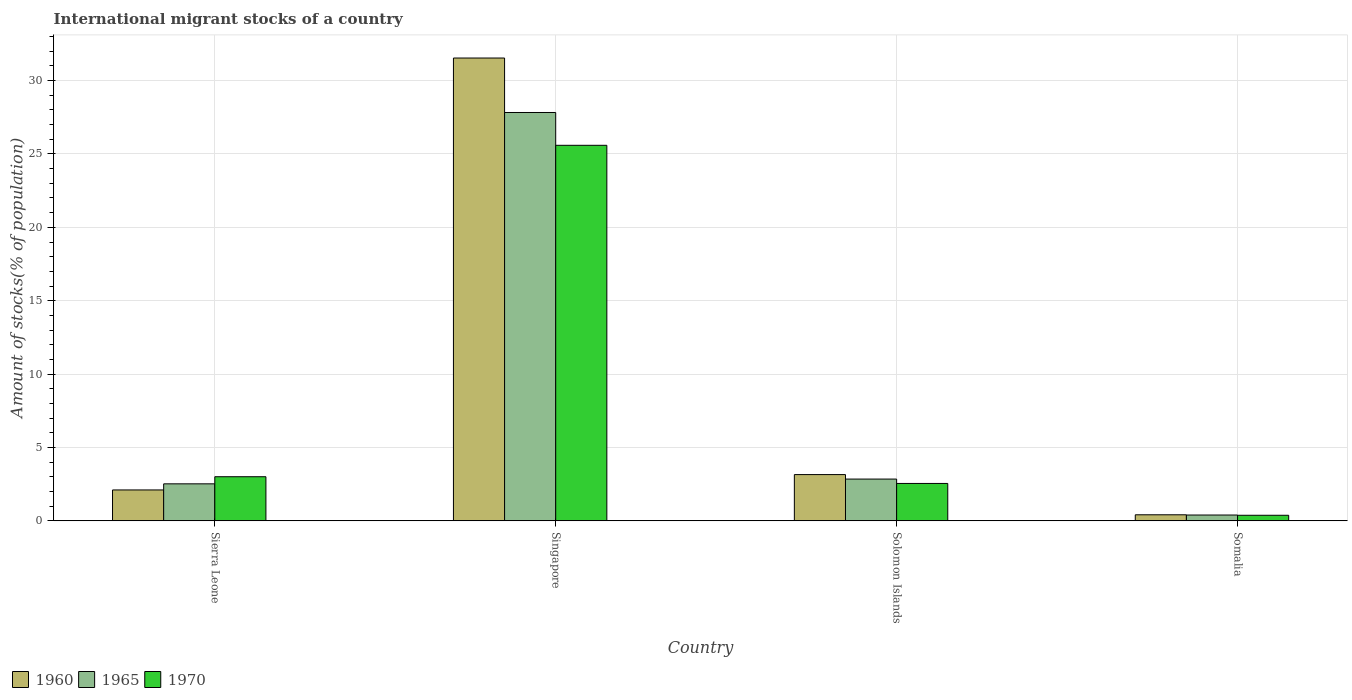How many different coloured bars are there?
Keep it short and to the point. 3. How many groups of bars are there?
Make the answer very short. 4. Are the number of bars per tick equal to the number of legend labels?
Provide a short and direct response. Yes. Are the number of bars on each tick of the X-axis equal?
Make the answer very short. Yes. How many bars are there on the 1st tick from the right?
Offer a terse response. 3. What is the label of the 3rd group of bars from the left?
Offer a very short reply. Solomon Islands. In how many cases, is the number of bars for a given country not equal to the number of legend labels?
Your answer should be compact. 0. What is the amount of stocks in in 1970 in Sierra Leone?
Your response must be concise. 3.01. Across all countries, what is the maximum amount of stocks in in 1960?
Your answer should be compact. 31.54. Across all countries, what is the minimum amount of stocks in in 1960?
Offer a very short reply. 0.41. In which country was the amount of stocks in in 1960 maximum?
Offer a terse response. Singapore. In which country was the amount of stocks in in 1965 minimum?
Your answer should be very brief. Somalia. What is the total amount of stocks in in 1960 in the graph?
Offer a very short reply. 37.21. What is the difference between the amount of stocks in in 1970 in Sierra Leone and that in Solomon Islands?
Keep it short and to the point. 0.46. What is the difference between the amount of stocks in in 1965 in Somalia and the amount of stocks in in 1970 in Solomon Islands?
Give a very brief answer. -2.15. What is the average amount of stocks in in 1960 per country?
Offer a terse response. 9.3. What is the difference between the amount of stocks in of/in 1970 and amount of stocks in of/in 1965 in Singapore?
Make the answer very short. -2.24. What is the ratio of the amount of stocks in in 1965 in Singapore to that in Somalia?
Offer a terse response. 70.38. Is the amount of stocks in in 1960 in Singapore less than that in Solomon Islands?
Your answer should be compact. No. What is the difference between the highest and the second highest amount of stocks in in 1970?
Offer a very short reply. 23.04. What is the difference between the highest and the lowest amount of stocks in in 1960?
Your answer should be compact. 31.13. Is the sum of the amount of stocks in in 1960 in Sierra Leone and Solomon Islands greater than the maximum amount of stocks in in 1965 across all countries?
Offer a terse response. No. What does the 1st bar from the left in Sierra Leone represents?
Make the answer very short. 1960. What does the 2nd bar from the right in Somalia represents?
Your response must be concise. 1965. Is it the case that in every country, the sum of the amount of stocks in in 1965 and amount of stocks in in 1970 is greater than the amount of stocks in in 1960?
Provide a short and direct response. Yes. Are all the bars in the graph horizontal?
Make the answer very short. No. How many countries are there in the graph?
Your response must be concise. 4. What is the difference between two consecutive major ticks on the Y-axis?
Give a very brief answer. 5. Are the values on the major ticks of Y-axis written in scientific E-notation?
Your answer should be very brief. No. How many legend labels are there?
Make the answer very short. 3. How are the legend labels stacked?
Offer a terse response. Horizontal. What is the title of the graph?
Make the answer very short. International migrant stocks of a country. Does "1974" appear as one of the legend labels in the graph?
Give a very brief answer. No. What is the label or title of the Y-axis?
Give a very brief answer. Amount of stocks(% of population). What is the Amount of stocks(% of population) in 1960 in Sierra Leone?
Your answer should be very brief. 2.1. What is the Amount of stocks(% of population) in 1965 in Sierra Leone?
Offer a terse response. 2.52. What is the Amount of stocks(% of population) in 1970 in Sierra Leone?
Ensure brevity in your answer.  3.01. What is the Amount of stocks(% of population) in 1960 in Singapore?
Ensure brevity in your answer.  31.54. What is the Amount of stocks(% of population) of 1965 in Singapore?
Give a very brief answer. 27.83. What is the Amount of stocks(% of population) of 1970 in Singapore?
Make the answer very short. 25.59. What is the Amount of stocks(% of population) in 1960 in Solomon Islands?
Your answer should be very brief. 3.15. What is the Amount of stocks(% of population) of 1965 in Solomon Islands?
Ensure brevity in your answer.  2.85. What is the Amount of stocks(% of population) of 1970 in Solomon Islands?
Offer a very short reply. 2.55. What is the Amount of stocks(% of population) of 1960 in Somalia?
Your answer should be compact. 0.41. What is the Amount of stocks(% of population) of 1965 in Somalia?
Give a very brief answer. 0.4. What is the Amount of stocks(% of population) of 1970 in Somalia?
Keep it short and to the point. 0.38. Across all countries, what is the maximum Amount of stocks(% of population) in 1960?
Your answer should be compact. 31.54. Across all countries, what is the maximum Amount of stocks(% of population) in 1965?
Give a very brief answer. 27.83. Across all countries, what is the maximum Amount of stocks(% of population) in 1970?
Provide a short and direct response. 25.59. Across all countries, what is the minimum Amount of stocks(% of population) in 1960?
Give a very brief answer. 0.41. Across all countries, what is the minimum Amount of stocks(% of population) in 1965?
Give a very brief answer. 0.4. Across all countries, what is the minimum Amount of stocks(% of population) in 1970?
Give a very brief answer. 0.38. What is the total Amount of stocks(% of population) in 1960 in the graph?
Your answer should be very brief. 37.21. What is the total Amount of stocks(% of population) in 1965 in the graph?
Offer a very short reply. 33.59. What is the total Amount of stocks(% of population) in 1970 in the graph?
Ensure brevity in your answer.  31.52. What is the difference between the Amount of stocks(% of population) of 1960 in Sierra Leone and that in Singapore?
Ensure brevity in your answer.  -29.43. What is the difference between the Amount of stocks(% of population) of 1965 in Sierra Leone and that in Singapore?
Provide a short and direct response. -25.31. What is the difference between the Amount of stocks(% of population) in 1970 in Sierra Leone and that in Singapore?
Ensure brevity in your answer.  -22.58. What is the difference between the Amount of stocks(% of population) of 1960 in Sierra Leone and that in Solomon Islands?
Offer a terse response. -1.05. What is the difference between the Amount of stocks(% of population) in 1965 in Sierra Leone and that in Solomon Islands?
Offer a very short reply. -0.33. What is the difference between the Amount of stocks(% of population) of 1970 in Sierra Leone and that in Solomon Islands?
Provide a short and direct response. 0.46. What is the difference between the Amount of stocks(% of population) in 1960 in Sierra Leone and that in Somalia?
Your response must be concise. 1.69. What is the difference between the Amount of stocks(% of population) in 1965 in Sierra Leone and that in Somalia?
Your answer should be compact. 2.13. What is the difference between the Amount of stocks(% of population) of 1970 in Sierra Leone and that in Somalia?
Provide a short and direct response. 2.63. What is the difference between the Amount of stocks(% of population) of 1960 in Singapore and that in Solomon Islands?
Provide a short and direct response. 28.39. What is the difference between the Amount of stocks(% of population) of 1965 in Singapore and that in Solomon Islands?
Give a very brief answer. 24.98. What is the difference between the Amount of stocks(% of population) of 1970 in Singapore and that in Solomon Islands?
Provide a succinct answer. 23.04. What is the difference between the Amount of stocks(% of population) of 1960 in Singapore and that in Somalia?
Keep it short and to the point. 31.13. What is the difference between the Amount of stocks(% of population) of 1965 in Singapore and that in Somalia?
Make the answer very short. 27.43. What is the difference between the Amount of stocks(% of population) of 1970 in Singapore and that in Somalia?
Offer a very short reply. 25.21. What is the difference between the Amount of stocks(% of population) of 1960 in Solomon Islands and that in Somalia?
Your response must be concise. 2.74. What is the difference between the Amount of stocks(% of population) of 1965 in Solomon Islands and that in Somalia?
Give a very brief answer. 2.45. What is the difference between the Amount of stocks(% of population) in 1970 in Solomon Islands and that in Somalia?
Keep it short and to the point. 2.17. What is the difference between the Amount of stocks(% of population) in 1960 in Sierra Leone and the Amount of stocks(% of population) in 1965 in Singapore?
Provide a succinct answer. -25.72. What is the difference between the Amount of stocks(% of population) of 1960 in Sierra Leone and the Amount of stocks(% of population) of 1970 in Singapore?
Your answer should be very brief. -23.49. What is the difference between the Amount of stocks(% of population) in 1965 in Sierra Leone and the Amount of stocks(% of population) in 1970 in Singapore?
Provide a succinct answer. -23.07. What is the difference between the Amount of stocks(% of population) of 1960 in Sierra Leone and the Amount of stocks(% of population) of 1965 in Solomon Islands?
Your response must be concise. -0.74. What is the difference between the Amount of stocks(% of population) of 1960 in Sierra Leone and the Amount of stocks(% of population) of 1970 in Solomon Islands?
Give a very brief answer. -0.44. What is the difference between the Amount of stocks(% of population) of 1965 in Sierra Leone and the Amount of stocks(% of population) of 1970 in Solomon Islands?
Keep it short and to the point. -0.03. What is the difference between the Amount of stocks(% of population) of 1960 in Sierra Leone and the Amount of stocks(% of population) of 1965 in Somalia?
Make the answer very short. 1.71. What is the difference between the Amount of stocks(% of population) of 1960 in Sierra Leone and the Amount of stocks(% of population) of 1970 in Somalia?
Provide a short and direct response. 1.73. What is the difference between the Amount of stocks(% of population) in 1965 in Sierra Leone and the Amount of stocks(% of population) in 1970 in Somalia?
Give a very brief answer. 2.14. What is the difference between the Amount of stocks(% of population) in 1960 in Singapore and the Amount of stocks(% of population) in 1965 in Solomon Islands?
Offer a very short reply. 28.69. What is the difference between the Amount of stocks(% of population) of 1960 in Singapore and the Amount of stocks(% of population) of 1970 in Solomon Islands?
Your response must be concise. 28.99. What is the difference between the Amount of stocks(% of population) of 1965 in Singapore and the Amount of stocks(% of population) of 1970 in Solomon Islands?
Your answer should be compact. 25.28. What is the difference between the Amount of stocks(% of population) in 1960 in Singapore and the Amount of stocks(% of population) in 1965 in Somalia?
Give a very brief answer. 31.14. What is the difference between the Amount of stocks(% of population) in 1960 in Singapore and the Amount of stocks(% of population) in 1970 in Somalia?
Provide a short and direct response. 31.16. What is the difference between the Amount of stocks(% of population) in 1965 in Singapore and the Amount of stocks(% of population) in 1970 in Somalia?
Make the answer very short. 27.45. What is the difference between the Amount of stocks(% of population) in 1960 in Solomon Islands and the Amount of stocks(% of population) in 1965 in Somalia?
Your response must be concise. 2.76. What is the difference between the Amount of stocks(% of population) in 1960 in Solomon Islands and the Amount of stocks(% of population) in 1970 in Somalia?
Make the answer very short. 2.77. What is the difference between the Amount of stocks(% of population) of 1965 in Solomon Islands and the Amount of stocks(% of population) of 1970 in Somalia?
Provide a short and direct response. 2.47. What is the average Amount of stocks(% of population) of 1960 per country?
Make the answer very short. 9.3. What is the average Amount of stocks(% of population) of 1965 per country?
Your response must be concise. 8.4. What is the average Amount of stocks(% of population) of 1970 per country?
Make the answer very short. 7.88. What is the difference between the Amount of stocks(% of population) of 1960 and Amount of stocks(% of population) of 1965 in Sierra Leone?
Keep it short and to the point. -0.42. What is the difference between the Amount of stocks(% of population) of 1960 and Amount of stocks(% of population) of 1970 in Sierra Leone?
Ensure brevity in your answer.  -0.9. What is the difference between the Amount of stocks(% of population) of 1965 and Amount of stocks(% of population) of 1970 in Sierra Leone?
Your answer should be compact. -0.49. What is the difference between the Amount of stocks(% of population) of 1960 and Amount of stocks(% of population) of 1965 in Singapore?
Your response must be concise. 3.71. What is the difference between the Amount of stocks(% of population) in 1960 and Amount of stocks(% of population) in 1970 in Singapore?
Make the answer very short. 5.95. What is the difference between the Amount of stocks(% of population) of 1965 and Amount of stocks(% of population) of 1970 in Singapore?
Give a very brief answer. 2.24. What is the difference between the Amount of stocks(% of population) of 1960 and Amount of stocks(% of population) of 1965 in Solomon Islands?
Provide a succinct answer. 0.31. What is the difference between the Amount of stocks(% of population) in 1960 and Amount of stocks(% of population) in 1970 in Solomon Islands?
Your answer should be very brief. 0.6. What is the difference between the Amount of stocks(% of population) in 1965 and Amount of stocks(% of population) in 1970 in Solomon Islands?
Offer a terse response. 0.3. What is the difference between the Amount of stocks(% of population) of 1960 and Amount of stocks(% of population) of 1965 in Somalia?
Offer a very short reply. 0.02. What is the difference between the Amount of stocks(% of population) in 1960 and Amount of stocks(% of population) in 1970 in Somalia?
Provide a succinct answer. 0.03. What is the difference between the Amount of stocks(% of population) in 1965 and Amount of stocks(% of population) in 1970 in Somalia?
Offer a very short reply. 0.02. What is the ratio of the Amount of stocks(% of population) of 1960 in Sierra Leone to that in Singapore?
Your answer should be compact. 0.07. What is the ratio of the Amount of stocks(% of population) in 1965 in Sierra Leone to that in Singapore?
Offer a terse response. 0.09. What is the ratio of the Amount of stocks(% of population) of 1970 in Sierra Leone to that in Singapore?
Give a very brief answer. 0.12. What is the ratio of the Amount of stocks(% of population) in 1960 in Sierra Leone to that in Solomon Islands?
Offer a very short reply. 0.67. What is the ratio of the Amount of stocks(% of population) in 1965 in Sierra Leone to that in Solomon Islands?
Offer a very short reply. 0.89. What is the ratio of the Amount of stocks(% of population) of 1970 in Sierra Leone to that in Solomon Islands?
Your answer should be very brief. 1.18. What is the ratio of the Amount of stocks(% of population) in 1960 in Sierra Leone to that in Somalia?
Your response must be concise. 5.11. What is the ratio of the Amount of stocks(% of population) in 1965 in Sierra Leone to that in Somalia?
Offer a terse response. 6.38. What is the ratio of the Amount of stocks(% of population) of 1970 in Sierra Leone to that in Somalia?
Provide a succinct answer. 7.94. What is the ratio of the Amount of stocks(% of population) of 1960 in Singapore to that in Solomon Islands?
Keep it short and to the point. 10.01. What is the ratio of the Amount of stocks(% of population) of 1965 in Singapore to that in Solomon Islands?
Make the answer very short. 9.78. What is the ratio of the Amount of stocks(% of population) in 1970 in Singapore to that in Solomon Islands?
Your response must be concise. 10.04. What is the ratio of the Amount of stocks(% of population) of 1960 in Singapore to that in Somalia?
Offer a very short reply. 76.55. What is the ratio of the Amount of stocks(% of population) of 1965 in Singapore to that in Somalia?
Your response must be concise. 70.38. What is the ratio of the Amount of stocks(% of population) in 1970 in Singapore to that in Somalia?
Keep it short and to the point. 67.61. What is the ratio of the Amount of stocks(% of population) of 1960 in Solomon Islands to that in Somalia?
Your answer should be very brief. 7.65. What is the ratio of the Amount of stocks(% of population) of 1965 in Solomon Islands to that in Somalia?
Keep it short and to the point. 7.2. What is the ratio of the Amount of stocks(% of population) of 1970 in Solomon Islands to that in Somalia?
Keep it short and to the point. 6.73. What is the difference between the highest and the second highest Amount of stocks(% of population) of 1960?
Offer a very short reply. 28.39. What is the difference between the highest and the second highest Amount of stocks(% of population) in 1965?
Provide a succinct answer. 24.98. What is the difference between the highest and the second highest Amount of stocks(% of population) in 1970?
Give a very brief answer. 22.58. What is the difference between the highest and the lowest Amount of stocks(% of population) of 1960?
Ensure brevity in your answer.  31.13. What is the difference between the highest and the lowest Amount of stocks(% of population) of 1965?
Offer a terse response. 27.43. What is the difference between the highest and the lowest Amount of stocks(% of population) in 1970?
Offer a terse response. 25.21. 